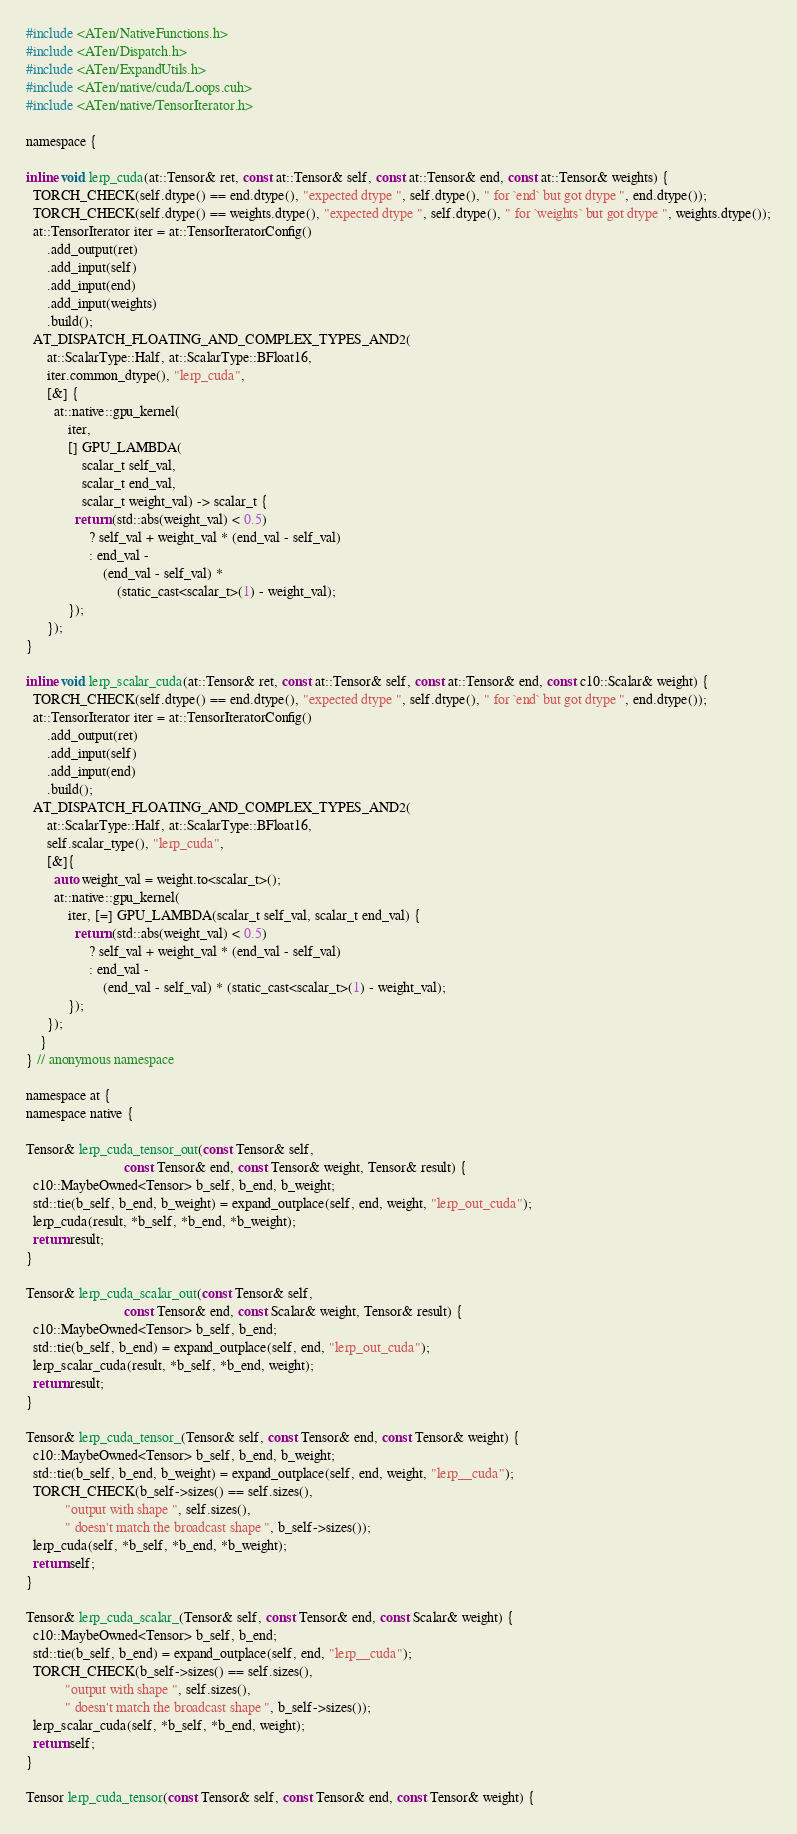Convert code to text. <code><loc_0><loc_0><loc_500><loc_500><_Cuda_>#include <ATen/NativeFunctions.h>
#include <ATen/Dispatch.h>
#include <ATen/ExpandUtils.h>
#include <ATen/native/cuda/Loops.cuh>
#include <ATen/native/TensorIterator.h>

namespace {

inline void lerp_cuda(at::Tensor& ret, const at::Tensor& self, const at::Tensor& end, const at::Tensor& weights) {
  TORCH_CHECK(self.dtype() == end.dtype(), "expected dtype ", self.dtype(), " for `end` but got dtype ", end.dtype());
  TORCH_CHECK(self.dtype() == weights.dtype(), "expected dtype ", self.dtype(), " for `weights` but got dtype ", weights.dtype());
  at::TensorIterator iter = at::TensorIteratorConfig()
      .add_output(ret)
      .add_input(self)
      .add_input(end)
      .add_input(weights)
      .build();
  AT_DISPATCH_FLOATING_AND_COMPLEX_TYPES_AND2(
      at::ScalarType::Half, at::ScalarType::BFloat16,
      iter.common_dtype(), "lerp_cuda",
      [&] {
        at::native::gpu_kernel(
            iter,
            [] GPU_LAMBDA(
                scalar_t self_val,
                scalar_t end_val,
                scalar_t weight_val) -> scalar_t {
              return (std::abs(weight_val) < 0.5)
                  ? self_val + weight_val * (end_val - self_val)
                  : end_val -
                      (end_val - self_val) *
                          (static_cast<scalar_t>(1) - weight_val);
            });
      });
}

inline void lerp_scalar_cuda(at::Tensor& ret, const at::Tensor& self, const at::Tensor& end, const c10::Scalar& weight) {
  TORCH_CHECK(self.dtype() == end.dtype(), "expected dtype ", self.dtype(), " for `end` but got dtype ", end.dtype());
  at::TensorIterator iter = at::TensorIteratorConfig()
      .add_output(ret)
      .add_input(self)
      .add_input(end)
      .build();
  AT_DISPATCH_FLOATING_AND_COMPLEX_TYPES_AND2(
      at::ScalarType::Half, at::ScalarType::BFloat16,
      self.scalar_type(), "lerp_cuda",
      [&]{
        auto weight_val = weight.to<scalar_t>();
        at::native::gpu_kernel(
            iter, [=] GPU_LAMBDA(scalar_t self_val, scalar_t end_val) {
              return (std::abs(weight_val) < 0.5)
                  ? self_val + weight_val * (end_val - self_val)
                  : end_val -
                      (end_val - self_val) * (static_cast<scalar_t>(1) - weight_val);
            });
      });
    }
} // anonymous namespace

namespace at {
namespace native {

Tensor& lerp_cuda_tensor_out(const Tensor& self,
                            const Tensor& end, const Tensor& weight, Tensor& result) {
  c10::MaybeOwned<Tensor> b_self, b_end, b_weight;
  std::tie(b_self, b_end, b_weight) = expand_outplace(self, end, weight, "lerp_out_cuda");
  lerp_cuda(result, *b_self, *b_end, *b_weight);
  return result;
}

Tensor& lerp_cuda_scalar_out(const Tensor& self,
                            const Tensor& end, const Scalar& weight, Tensor& result) {
  c10::MaybeOwned<Tensor> b_self, b_end;
  std::tie(b_self, b_end) = expand_outplace(self, end, "lerp_out_cuda");
  lerp_scalar_cuda(result, *b_self, *b_end, weight);
  return result;
}

Tensor& lerp_cuda_tensor_(Tensor& self, const Tensor& end, const Tensor& weight) {
  c10::MaybeOwned<Tensor> b_self, b_end, b_weight;
  std::tie(b_self, b_end, b_weight) = expand_outplace(self, end, weight, "lerp__cuda");
  TORCH_CHECK(b_self->sizes() == self.sizes(),
           "output with shape ", self.sizes(),
           " doesn't match the broadcast shape ", b_self->sizes());
  lerp_cuda(self, *b_self, *b_end, *b_weight);
  return self;
}

Tensor& lerp_cuda_scalar_(Tensor& self, const Tensor& end, const Scalar& weight) {
  c10::MaybeOwned<Tensor> b_self, b_end;
  std::tie(b_self, b_end) = expand_outplace(self, end, "lerp__cuda");
  TORCH_CHECK(b_self->sizes() == self.sizes(),
           "output with shape ", self.sizes(),
           " doesn't match the broadcast shape ", b_self->sizes());
  lerp_scalar_cuda(self, *b_self, *b_end, weight);
  return self;
}

Tensor lerp_cuda_tensor(const Tensor& self, const Tensor& end, const Tensor& weight) {</code> 